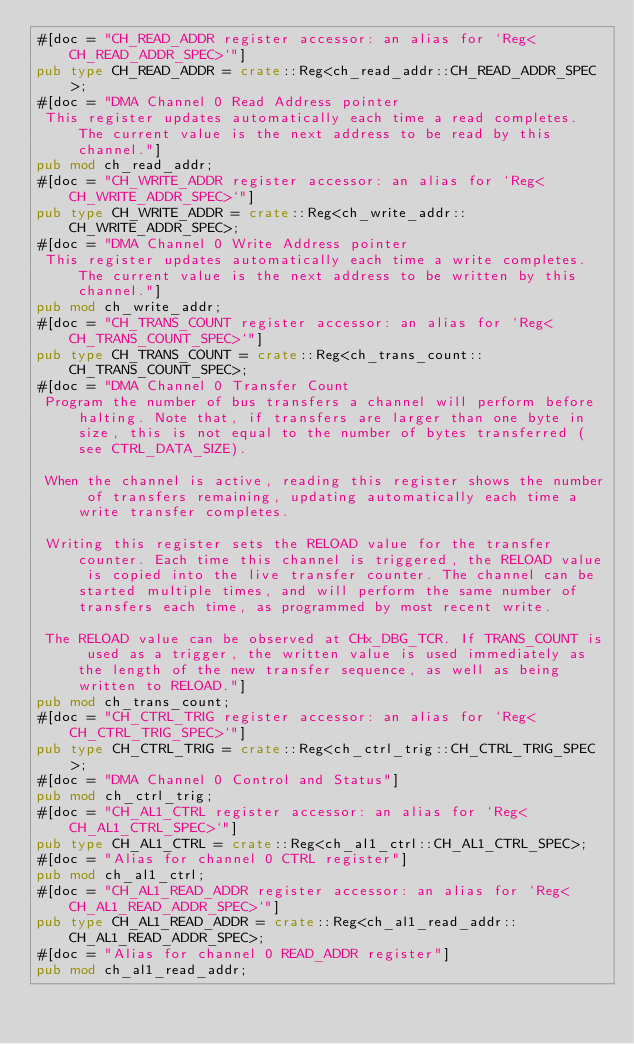Convert code to text. <code><loc_0><loc_0><loc_500><loc_500><_Rust_>#[doc = "CH_READ_ADDR register accessor: an alias for `Reg<CH_READ_ADDR_SPEC>`"]
pub type CH_READ_ADDR = crate::Reg<ch_read_addr::CH_READ_ADDR_SPEC>;
#[doc = "DMA Channel 0 Read Address pointer  
 This register updates automatically each time a read completes. The current value is the next address to be read by this channel."]
pub mod ch_read_addr;
#[doc = "CH_WRITE_ADDR register accessor: an alias for `Reg<CH_WRITE_ADDR_SPEC>`"]
pub type CH_WRITE_ADDR = crate::Reg<ch_write_addr::CH_WRITE_ADDR_SPEC>;
#[doc = "DMA Channel 0 Write Address pointer  
 This register updates automatically each time a write completes. The current value is the next address to be written by this channel."]
pub mod ch_write_addr;
#[doc = "CH_TRANS_COUNT register accessor: an alias for `Reg<CH_TRANS_COUNT_SPEC>`"]
pub type CH_TRANS_COUNT = crate::Reg<ch_trans_count::CH_TRANS_COUNT_SPEC>;
#[doc = "DMA Channel 0 Transfer Count  
 Program the number of bus transfers a channel will perform before halting. Note that, if transfers are larger than one byte in size, this is not equal to the number of bytes transferred (see CTRL_DATA_SIZE).  

 When the channel is active, reading this register shows the number of transfers remaining, updating automatically each time a write transfer completes.  

 Writing this register sets the RELOAD value for the transfer counter. Each time this channel is triggered, the RELOAD value is copied into the live transfer counter. The channel can be started multiple times, and will perform the same number of transfers each time, as programmed by most recent write.  

 The RELOAD value can be observed at CHx_DBG_TCR. If TRANS_COUNT is used as a trigger, the written value is used immediately as the length of the new transfer sequence, as well as being written to RELOAD."]
pub mod ch_trans_count;
#[doc = "CH_CTRL_TRIG register accessor: an alias for `Reg<CH_CTRL_TRIG_SPEC>`"]
pub type CH_CTRL_TRIG = crate::Reg<ch_ctrl_trig::CH_CTRL_TRIG_SPEC>;
#[doc = "DMA Channel 0 Control and Status"]
pub mod ch_ctrl_trig;
#[doc = "CH_AL1_CTRL register accessor: an alias for `Reg<CH_AL1_CTRL_SPEC>`"]
pub type CH_AL1_CTRL = crate::Reg<ch_al1_ctrl::CH_AL1_CTRL_SPEC>;
#[doc = "Alias for channel 0 CTRL register"]
pub mod ch_al1_ctrl;
#[doc = "CH_AL1_READ_ADDR register accessor: an alias for `Reg<CH_AL1_READ_ADDR_SPEC>`"]
pub type CH_AL1_READ_ADDR = crate::Reg<ch_al1_read_addr::CH_AL1_READ_ADDR_SPEC>;
#[doc = "Alias for channel 0 READ_ADDR register"]
pub mod ch_al1_read_addr;</code> 